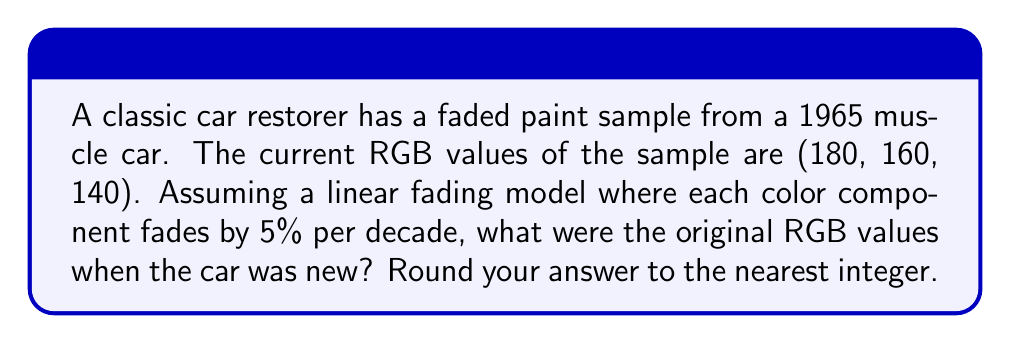Show me your answer to this math problem. To solve this problem, we need to work backwards from the current faded color to the original color. Let's approach this step-by-step:

1) First, we need to calculate how many decades have passed since 1965:
   Current year: 2023
   Years passed: 2023 - 1965 = 58 years
   Decades passed: 58 / 10 = 5.8 decades

2) Now, we know that each color component fades by 5% per decade. Over 5.8 decades, the total fading percentage is:
   $$ \text{Total fading} = 1 - (1 - 0.05)^{5.8} \approx 0.2551 \text{ or } 25.51\% $$

3) To find the original value, we need to divide the current value by the remaining percentage:
   $$ \text{Original value} = \frac{\text{Current value}}{1 - 0.2551} = \frac{\text{Current value}}{0.7449} $$

4) Let's apply this to each RGB component:

   Red:   $\frac{180}{0.7449} \approx 241.64$
   Green: $\frac{160}{0.7449} \approx 214.79$
   Blue:  $\frac{140}{0.7449} \approx 187.94$

5) Rounding to the nearest integer:

   Red:   242
   Green: 215
   Blue:  188

Therefore, the original RGB values were approximately (242, 215, 188).
Answer: (242, 215, 188) 